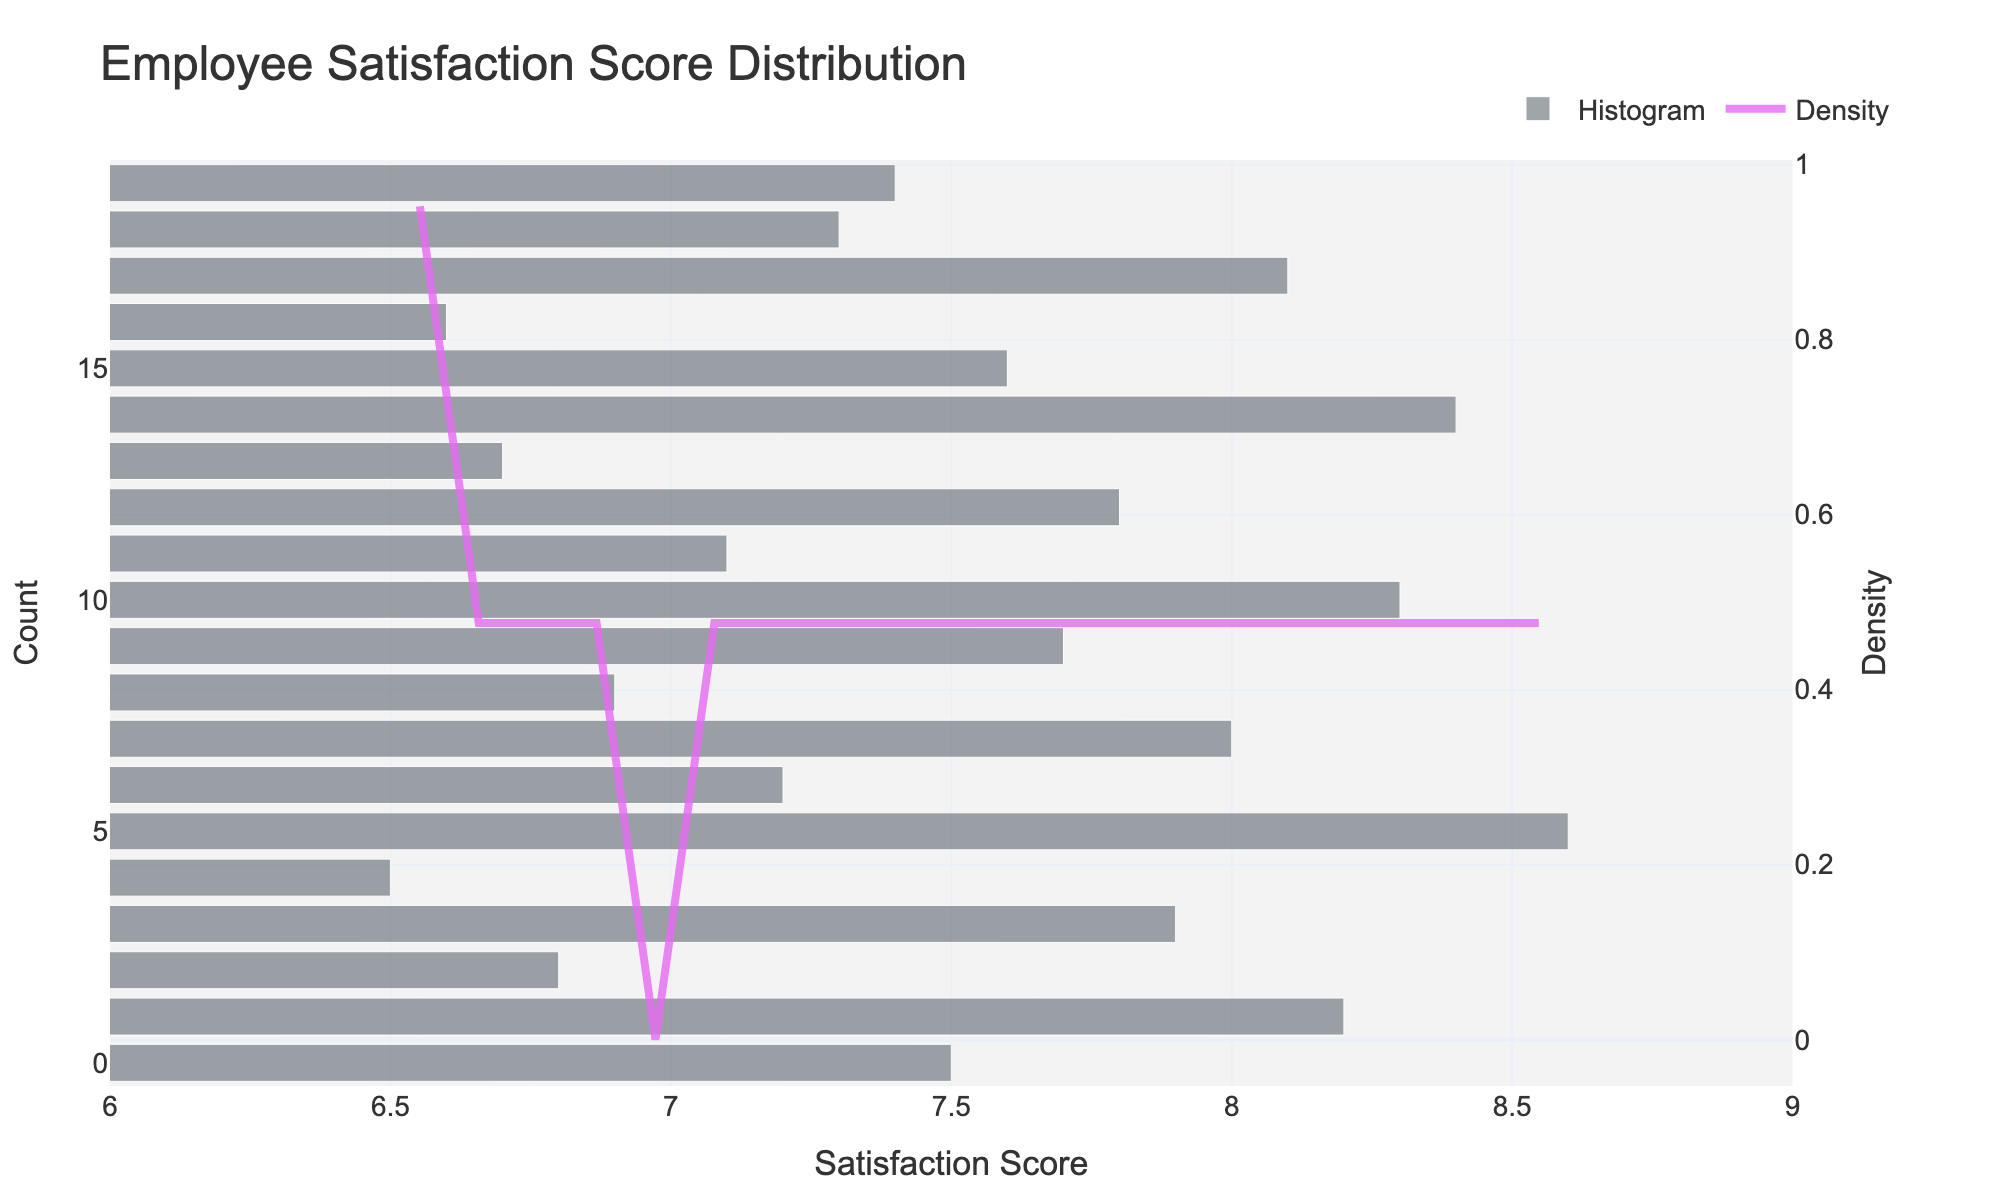What is the title of the plot? The title is usually displayed at the top of the figure and provides an overview of what the plot represents. In this case, it outlines the purpose of the plot.
Answer: Employee Satisfaction Score Distribution What is the x-axis labeled as? The x-axis label describes what is being measured along the horizontal axis. Here, it shows the range of employee satisfaction scores.
Answer: Satisfaction Score How many bins are used in the histogram? By examining the number of bars (bins) in the histogram, we can count how many discrete intervals the data is divided into.
Answer: 20 Which satisfaction score corresponds to the highest density on the KDE curve? To find this, locate the peak of the KDE curve and observe the corresponding x-axis value.
Answer: Around 7.5 What is the approximate range of satisfaction scores shown on the x-axis? The x-axis range is indicated by the minimum and maximum values displayed on the horizontal scale.
Answer: 6 to 9 Is there any visible skewness in the distribution of satisfaction scores? To determine skewness, observe the distribution of the bars and the shape of the KDE curve. If most scores pile up on one side, it indicates skewness.
Answer: Slightly right-skewed How does the density around a score of 7 compare to the density around a score of 8.5 on the KDE curve? Compare the heights of the KDE curve at these two points; a higher peak indicates greater density.
Answer: Density around 7 is higher than around 8.5 What is the approximate height of the tallest bar in the histogram? Identify the tallest bar and estimate or read off its height from the y-axis scale.
Answer: Around 3 What can you infer about employee satisfaction based on the distribution? Interpret the general shape and spread of the data. A clustered center around a particular score suggest common satisfaction level trends.
Answer: Most employees have satisfaction scores between 7 and 8 How does the density for a score of 7.5 compare to the density for a score of 6.5? Look at the KDE curve heights at scores of 7.5 and 6.5 to compare their relative densities.
Answer: Density for 7.5 is much higher than for 6.5 